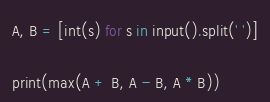<code> <loc_0><loc_0><loc_500><loc_500><_Python_>A, B = [int(s) for s in input().split(' ')]

print(max(A + B, A - B, A * B))
</code> 